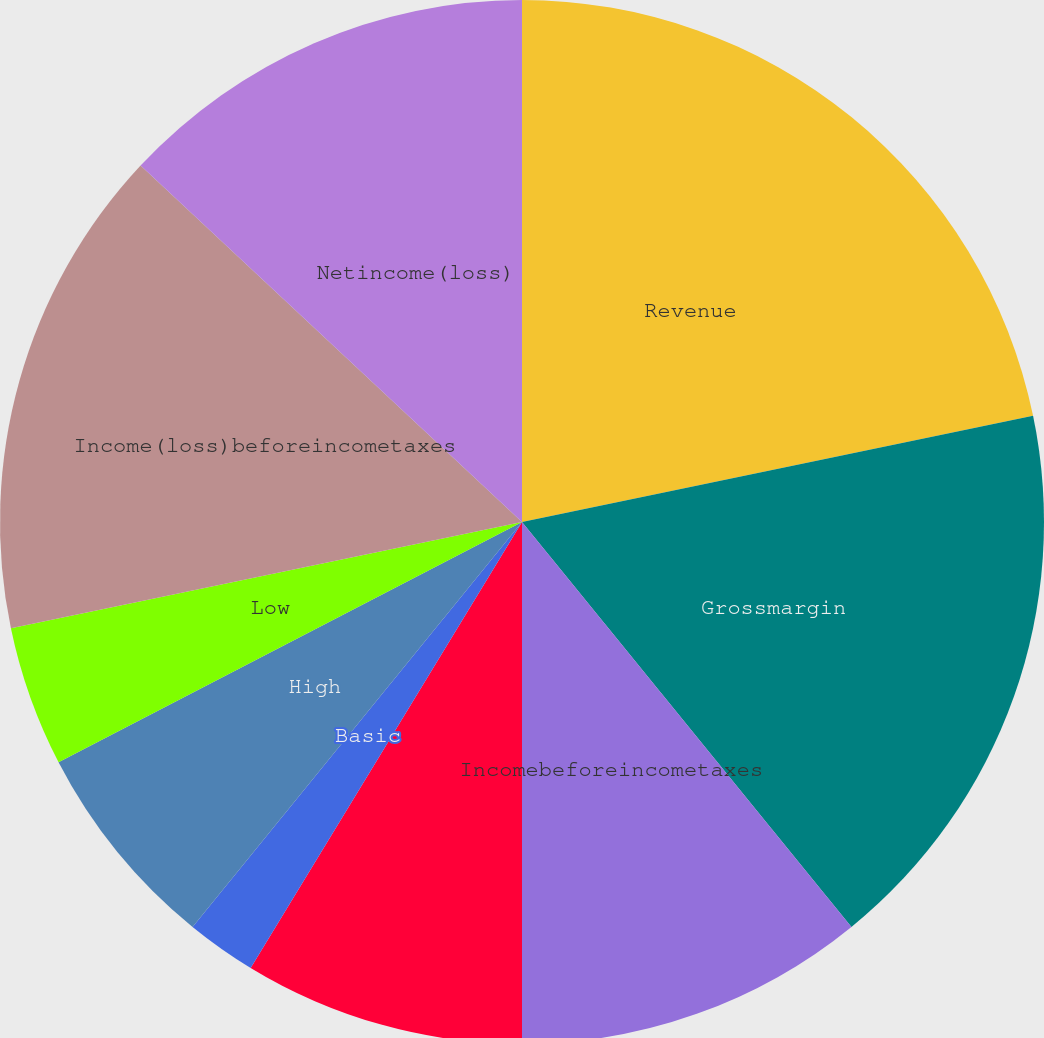Convert chart to OTSL. <chart><loc_0><loc_0><loc_500><loc_500><pie_chart><fcel>Revenue<fcel>Grossmargin<fcel>Incomebeforeincometaxes<fcel>Netincome<fcel>Basic<fcel>Diluted<fcel>High<fcel>Low<fcel>Income(loss)beforeincometaxes<fcel>Netincome(loss)<nl><fcel>21.74%<fcel>17.39%<fcel>10.87%<fcel>8.7%<fcel>2.17%<fcel>0.0%<fcel>6.52%<fcel>4.35%<fcel>15.22%<fcel>13.04%<nl></chart> 